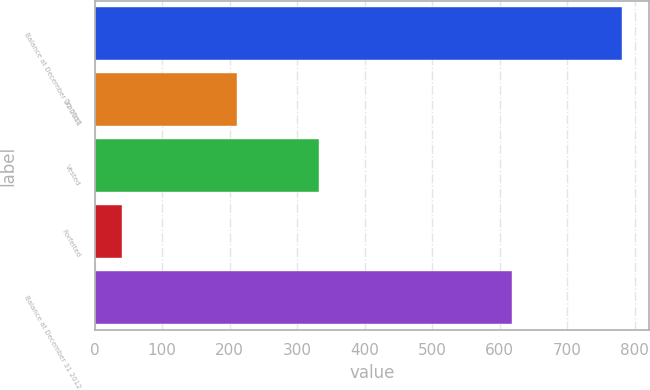Convert chart. <chart><loc_0><loc_0><loc_500><loc_500><bar_chart><fcel>Balance at December 31 2011<fcel>Granted<fcel>Vested<fcel>Forfeited<fcel>Balance at December 31 2012<nl><fcel>782<fcel>211<fcel>333<fcel>41<fcel>619<nl></chart> 